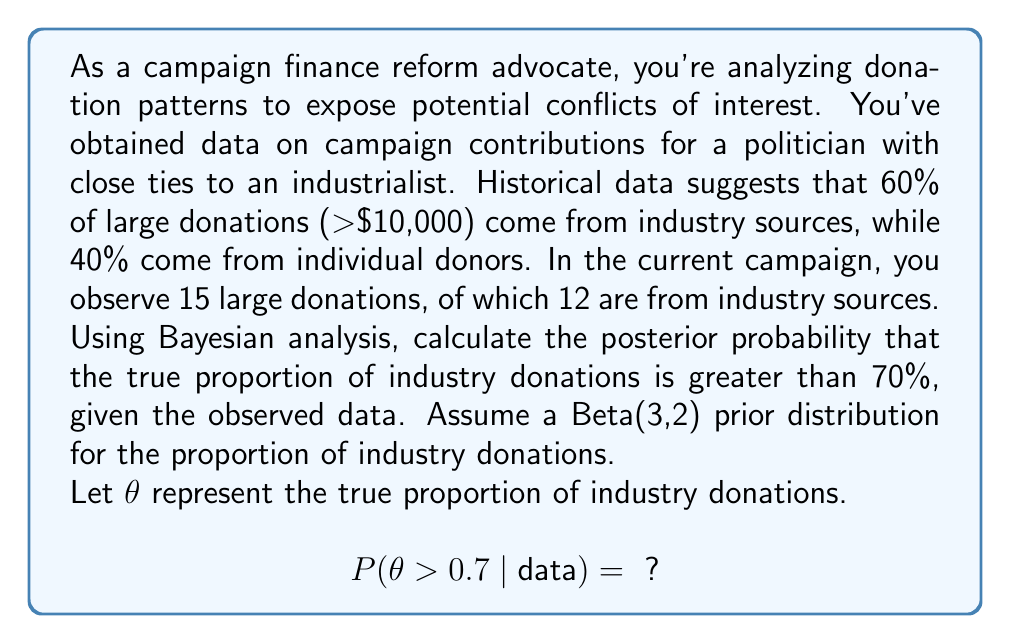Solve this math problem. To solve this problem, we'll use Bayesian inference with a Beta-Binomial model:

1) Prior: Beta(3,2)
2) Likelihood: Binomial(15, θ)
3) Posterior: Beta(3+12, 2+3) = Beta(15, 5)

Steps:

1. The posterior distribution is Beta(15, 5).

2. We need to calculate $P(\theta > 0.7 | \text{data})$, which is equivalent to $1 - P(\theta \leq 0.7 | \text{data})$.

3. For a Beta(α, β) distribution, the cumulative distribution function (CDF) is given by the regularized incomplete beta function:

   $P(\theta \leq x) = I_x(\alpha, \beta)$

4. We need to calculate $1 - I_{0.7}(15, 5)$.

5. This can be computed using statistical software or numerical integration. Using Python's scipy.stats module:

   ```python
   from scipy.stats import beta
   1 - beta.cdf(0.7, 15, 5)
   ```

6. This gives us approximately 0.8794.

Therefore, the posterior probability that the true proportion of industry donations is greater than 70% is about 0.8794 or 87.94%.

This high probability suggests strong evidence of increased industry influence in the politician's campaign financing, supporting the need for campaign finance reform.
Answer: $P(\theta > 0.7 | \text{data}) \approx 0.8794$ 